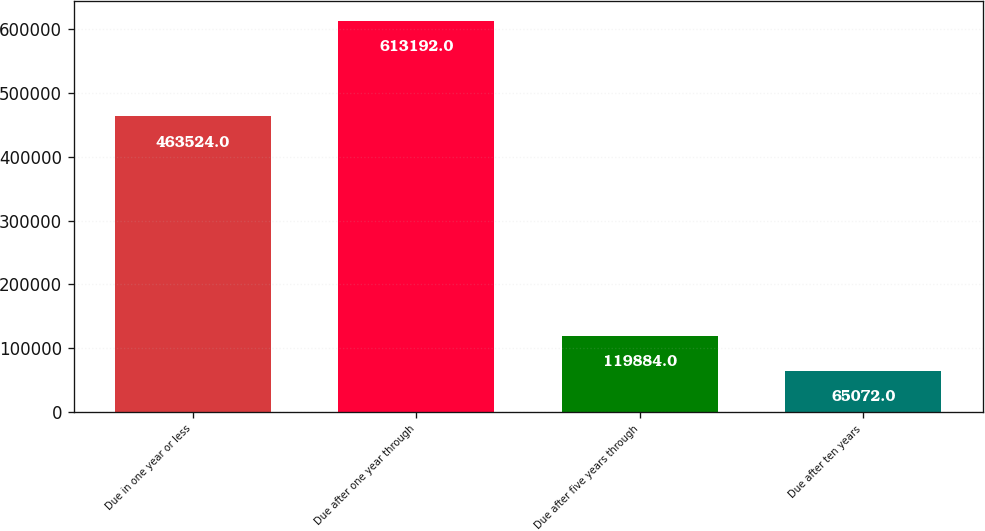Convert chart to OTSL. <chart><loc_0><loc_0><loc_500><loc_500><bar_chart><fcel>Due in one year or less<fcel>Due after one year through<fcel>Due after five years through<fcel>Due after ten years<nl><fcel>463524<fcel>613192<fcel>119884<fcel>65072<nl></chart> 